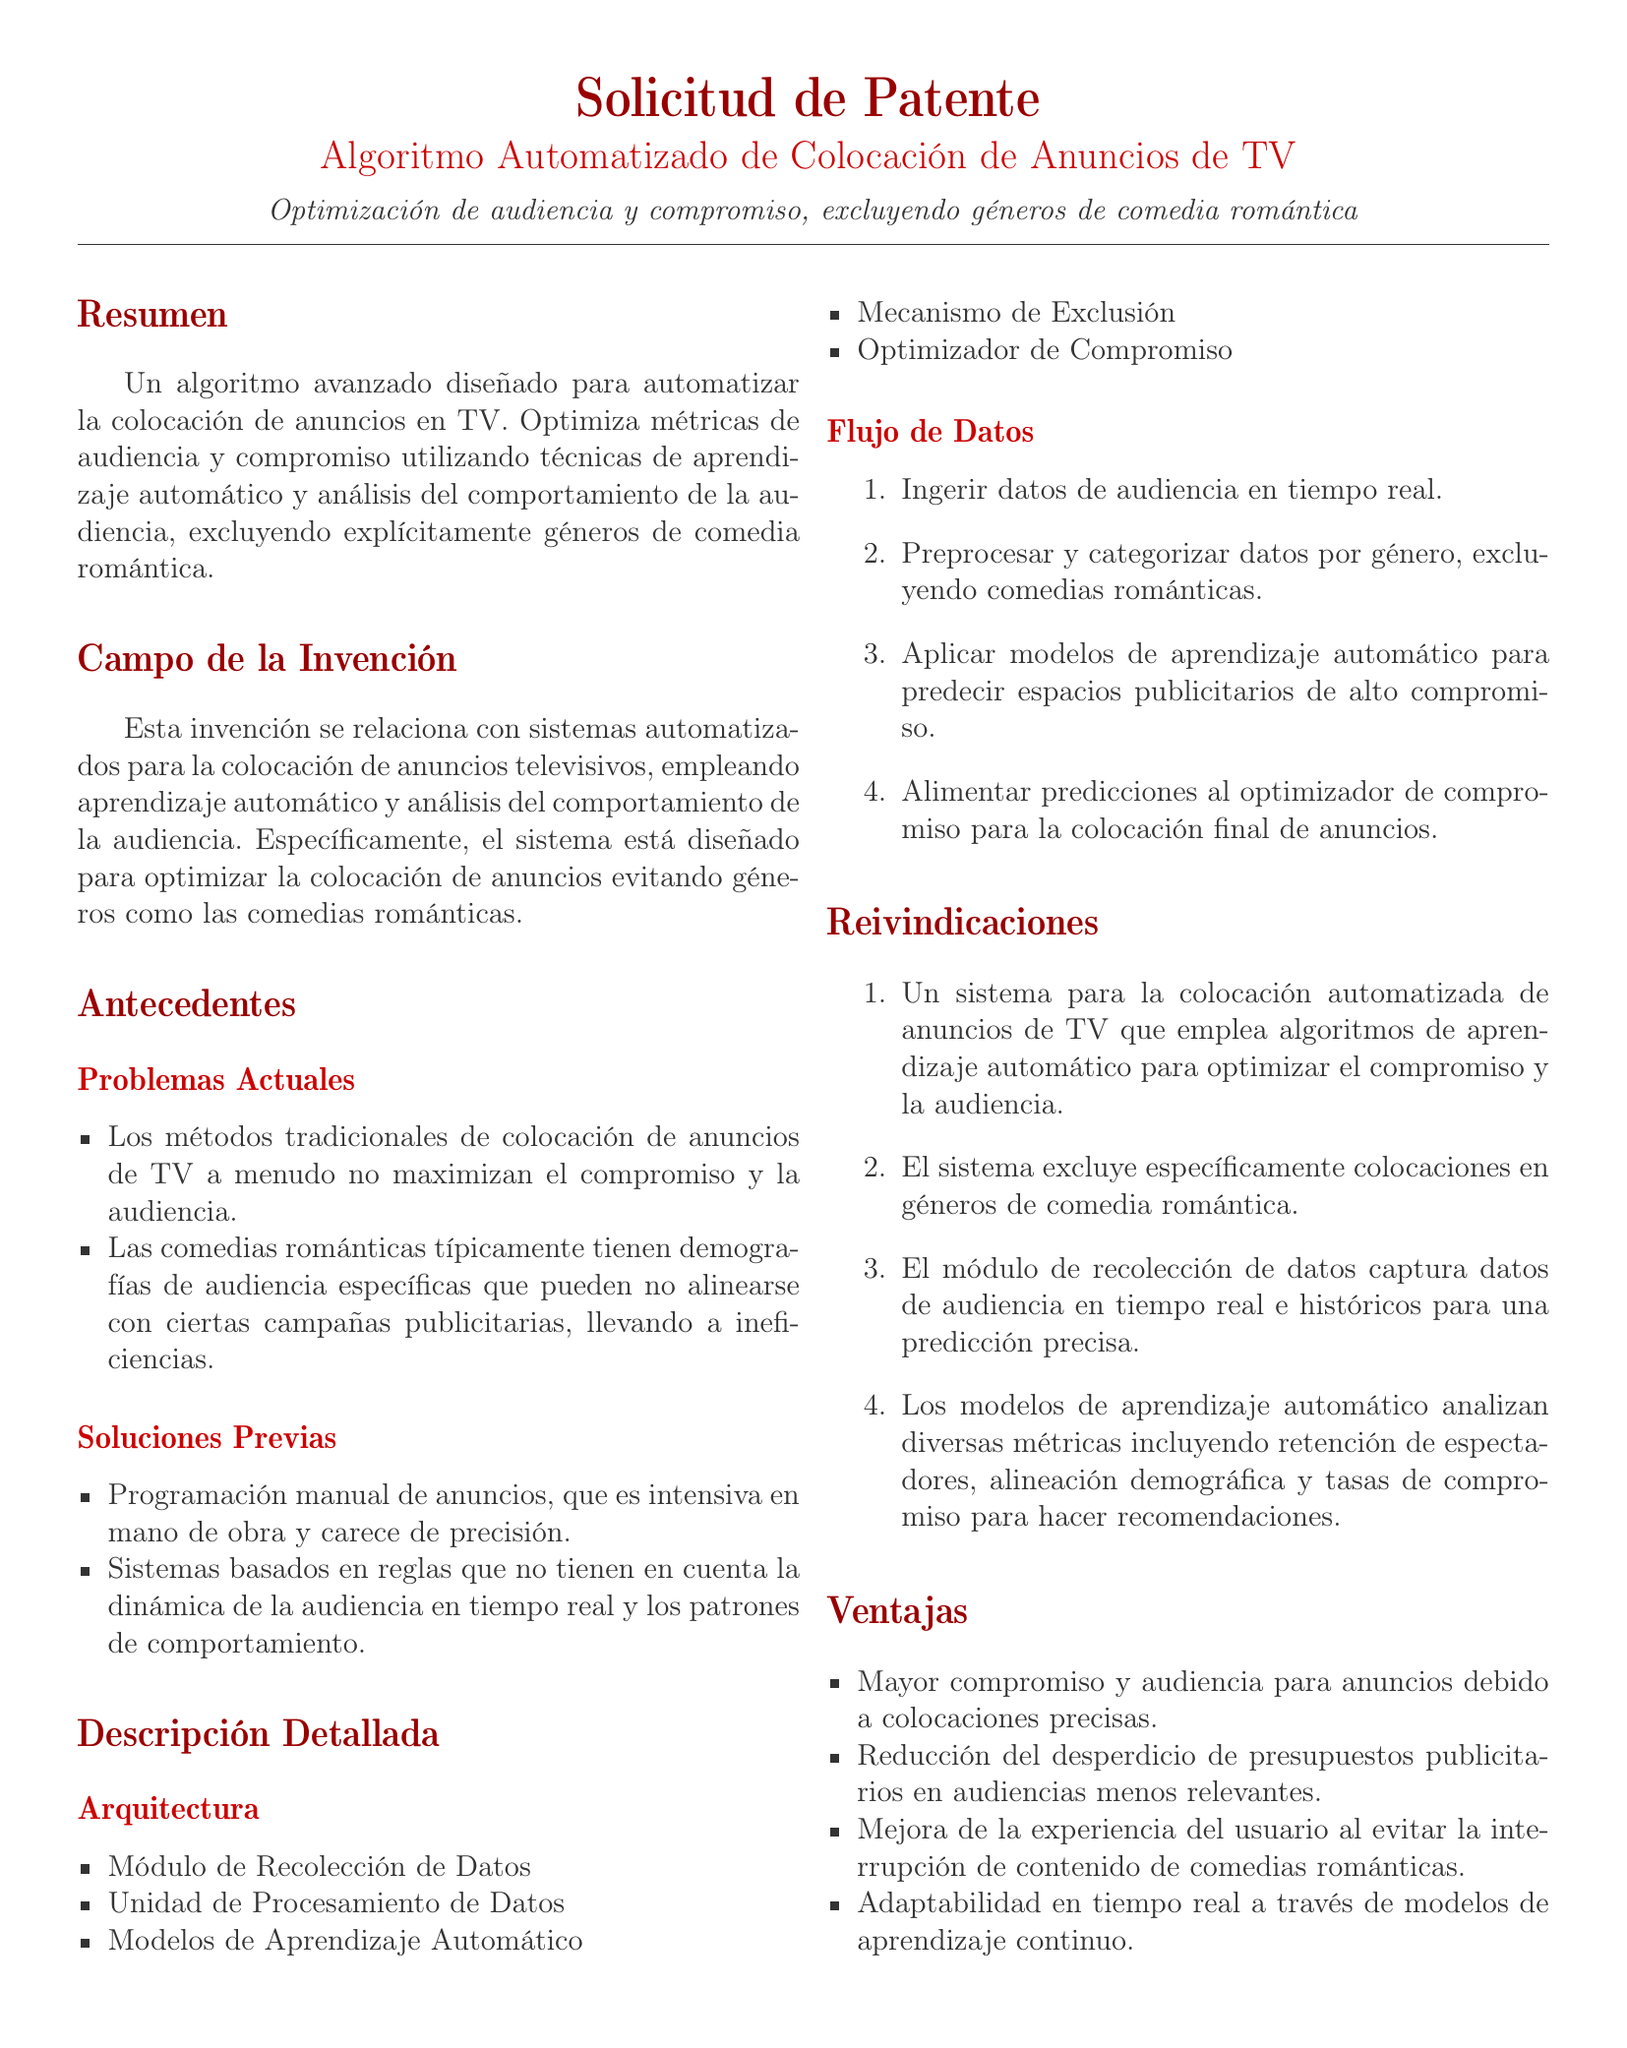¿Qué género se excluye del algoritmo? El algoritmo está diseñado para evitar la colocación de anuncios en géneros específicos, en este caso, las comedias románticas.
Answer: Comedia romántica ¿Qué optimiza el algoritmo de colocación de anuncios? El algoritmo busca maximizar métricas de audiencia y compromiso mediante técnicas avanzadas.
Answer: Audiencia y compromiso ¿Cuántos módulos se mencionan en la arquitectura del sistema? La sección de arquitectura menciona varios componentes que conforman el sistema automatizado de colocación de anuncios.
Answer: Cinco ¿Qué tipo de datos se recopilan en tiempo real? El módulo de recolección de datos se encarga de capturar información que es crucial para la optimización del algoritmo.
Answer: Datos de audiencia ¿Cuál es una de las ventajas mencionadas del algoritmo? Se describe una serie de beneficios que el sistema puede ofrecer, que incluyen una mejora en la interacción con el contenido publicitario.
Answer: Mayor compromiso ¿Qué metodología se utiliza para la previsión de colocaciones publicitarias? El documento explica que el sistema se basa en ciertas técnicas para llegar a conclusiones sobre la colocación óptima de anuncios.
Answer: Aprendizaje automático ¿Cuál es la finalidad del mecanismo de exclusión? Este componente del sistema tiene un propósito específico para filtrar ciertos tipos de contenido en el algoritmo.
Answer: Excluir géneros de comedia romántica ¿Cuál es el resultado esperado de utilizar el algoritmo en la colocación de anuncios? La aplicación del algoritmo busca reducir el gasto innecesario en campañas publicitarias poco efectivas por demografía.
Answer: Reducción del desperdicio de presupuestos publicitarios 